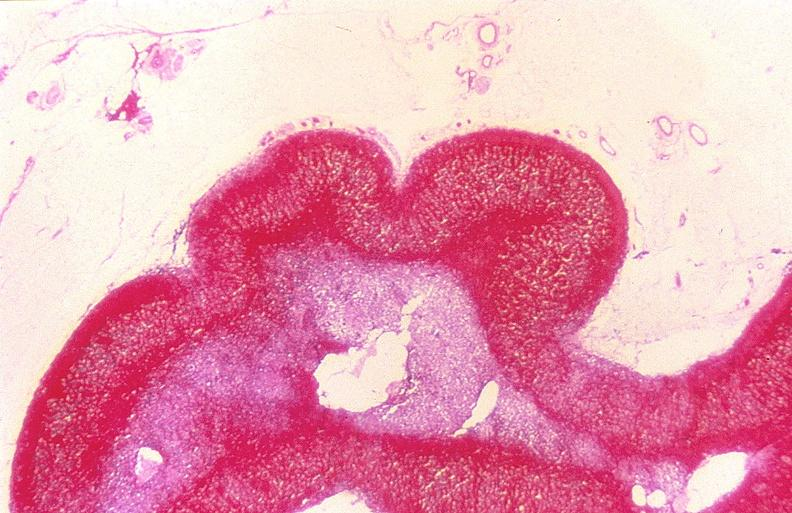does this image show adrenal gland, severe hemorrhage waterhouse-friderichsen syndrome?
Answer the question using a single word or phrase. Yes 